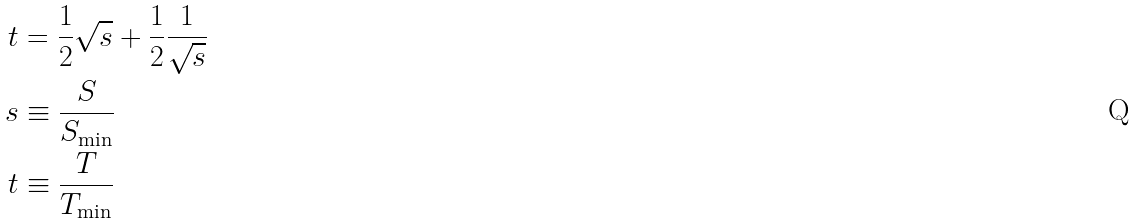<formula> <loc_0><loc_0><loc_500><loc_500>t & = \frac { 1 } { 2 } \sqrt { s } + \frac { 1 } { 2 } \frac { 1 } { \sqrt { s } } \\ s & \equiv \frac { S } { S _ { \min } } \\ t & \equiv \frac { T } { T _ { \min } } \\</formula> 